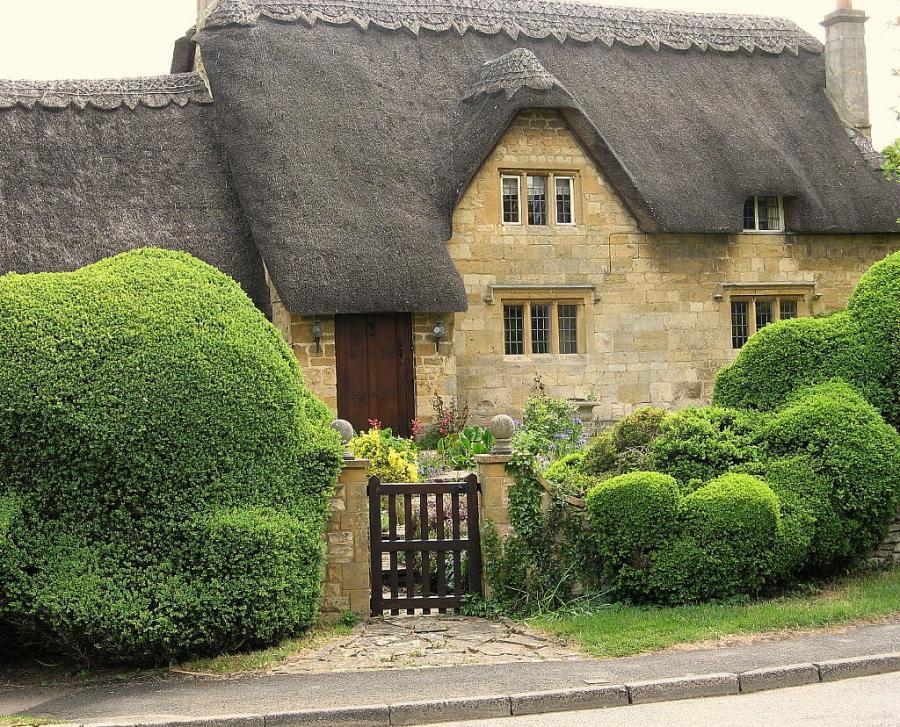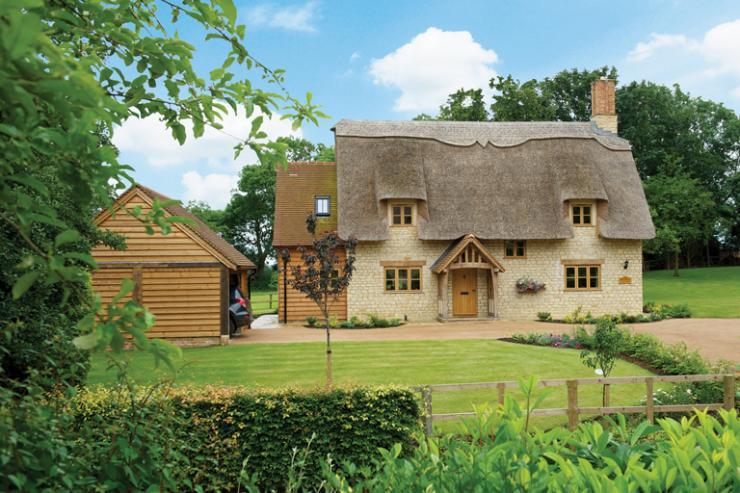The first image is the image on the left, the second image is the image on the right. For the images shown, is this caption "At least two humans are visible." true? Answer yes or no. No. The first image is the image on the left, the second image is the image on the right. Evaluate the accuracy of this statement regarding the images: "In at least one image there is a house with only one chimney on the right side.". Is it true? Answer yes or no. Yes. 